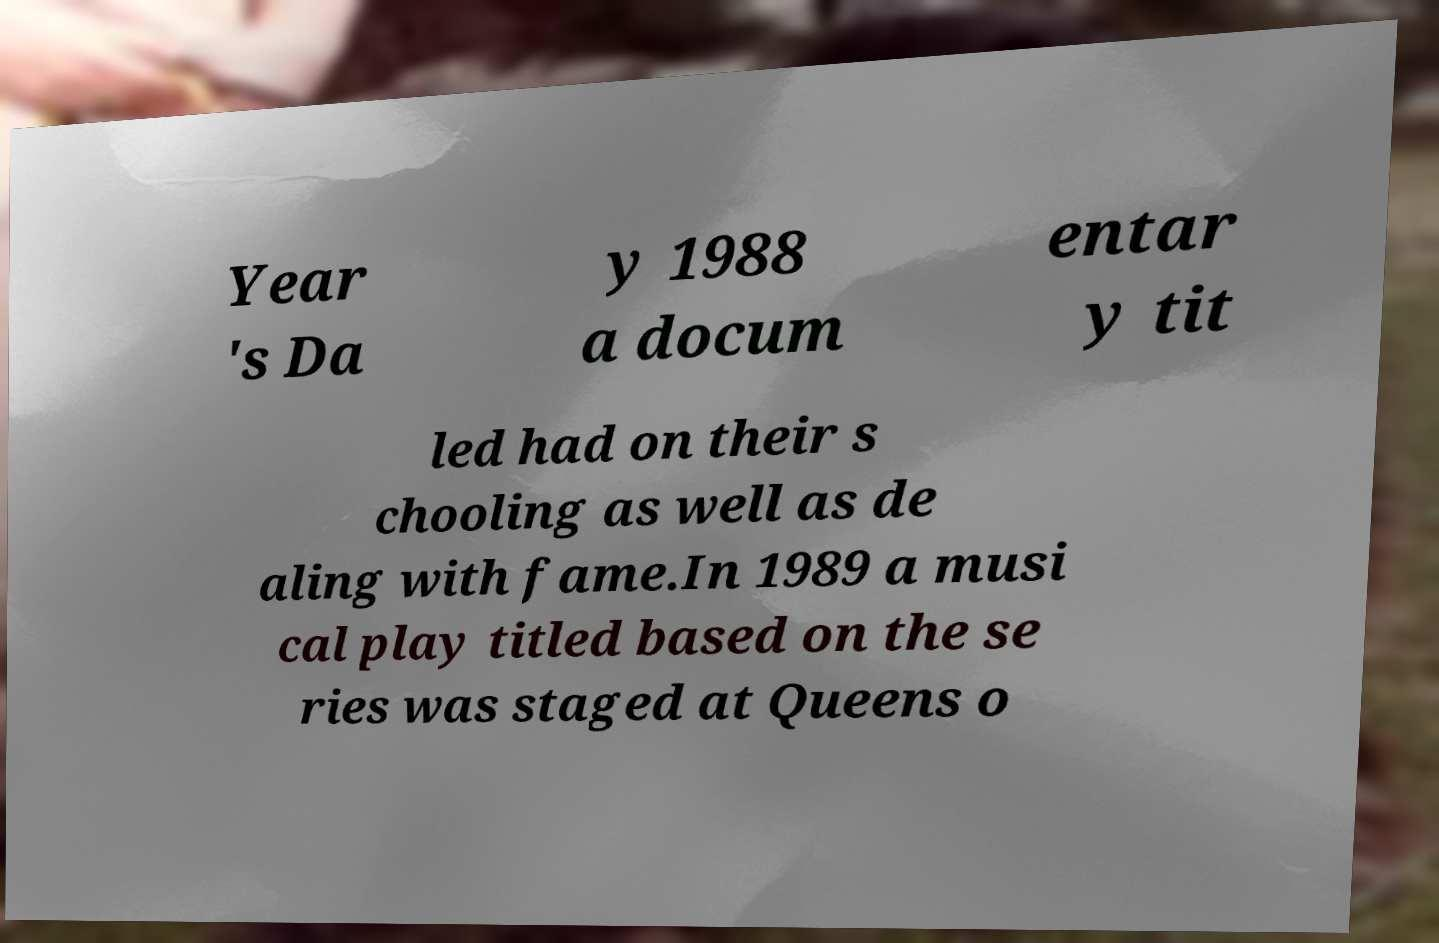Please read and relay the text visible in this image. What does it say? Year 's Da y 1988 a docum entar y tit led had on their s chooling as well as de aling with fame.In 1989 a musi cal play titled based on the se ries was staged at Queens o 